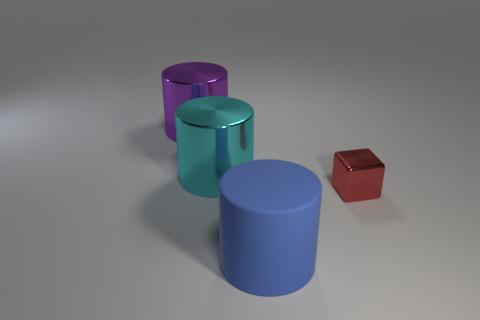Is there anything else that has the same size as the block?
Offer a terse response. No. Are there any other things that have the same material as the blue object?
Your answer should be very brief. No. Is the number of objects behind the big matte cylinder greater than the number of large shiny things that are on the left side of the purple object?
Make the answer very short. Yes. What material is the object in front of the small block?
Keep it short and to the point. Rubber. Does the cyan object have the same size as the purple metallic object?
Make the answer very short. Yes. How many other things are there of the same size as the cube?
Make the answer very short. 0. What is the shape of the thing to the right of the object that is in front of the metallic thing that is on the right side of the large blue thing?
Give a very brief answer. Cube. What number of things are either cylinders behind the matte thing or small blocks that are in front of the large purple shiny cylinder?
Keep it short and to the point. 3. There is a object that is on the right side of the large object that is in front of the cyan shiny cylinder; what size is it?
Your response must be concise. Small. Are there any rubber things that have the same shape as the cyan metallic object?
Provide a short and direct response. Yes. 